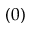<formula> <loc_0><loc_0><loc_500><loc_500>( 0 )</formula> 